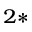<formula> <loc_0><loc_0><loc_500><loc_500>^ { 2 \ast }</formula> 